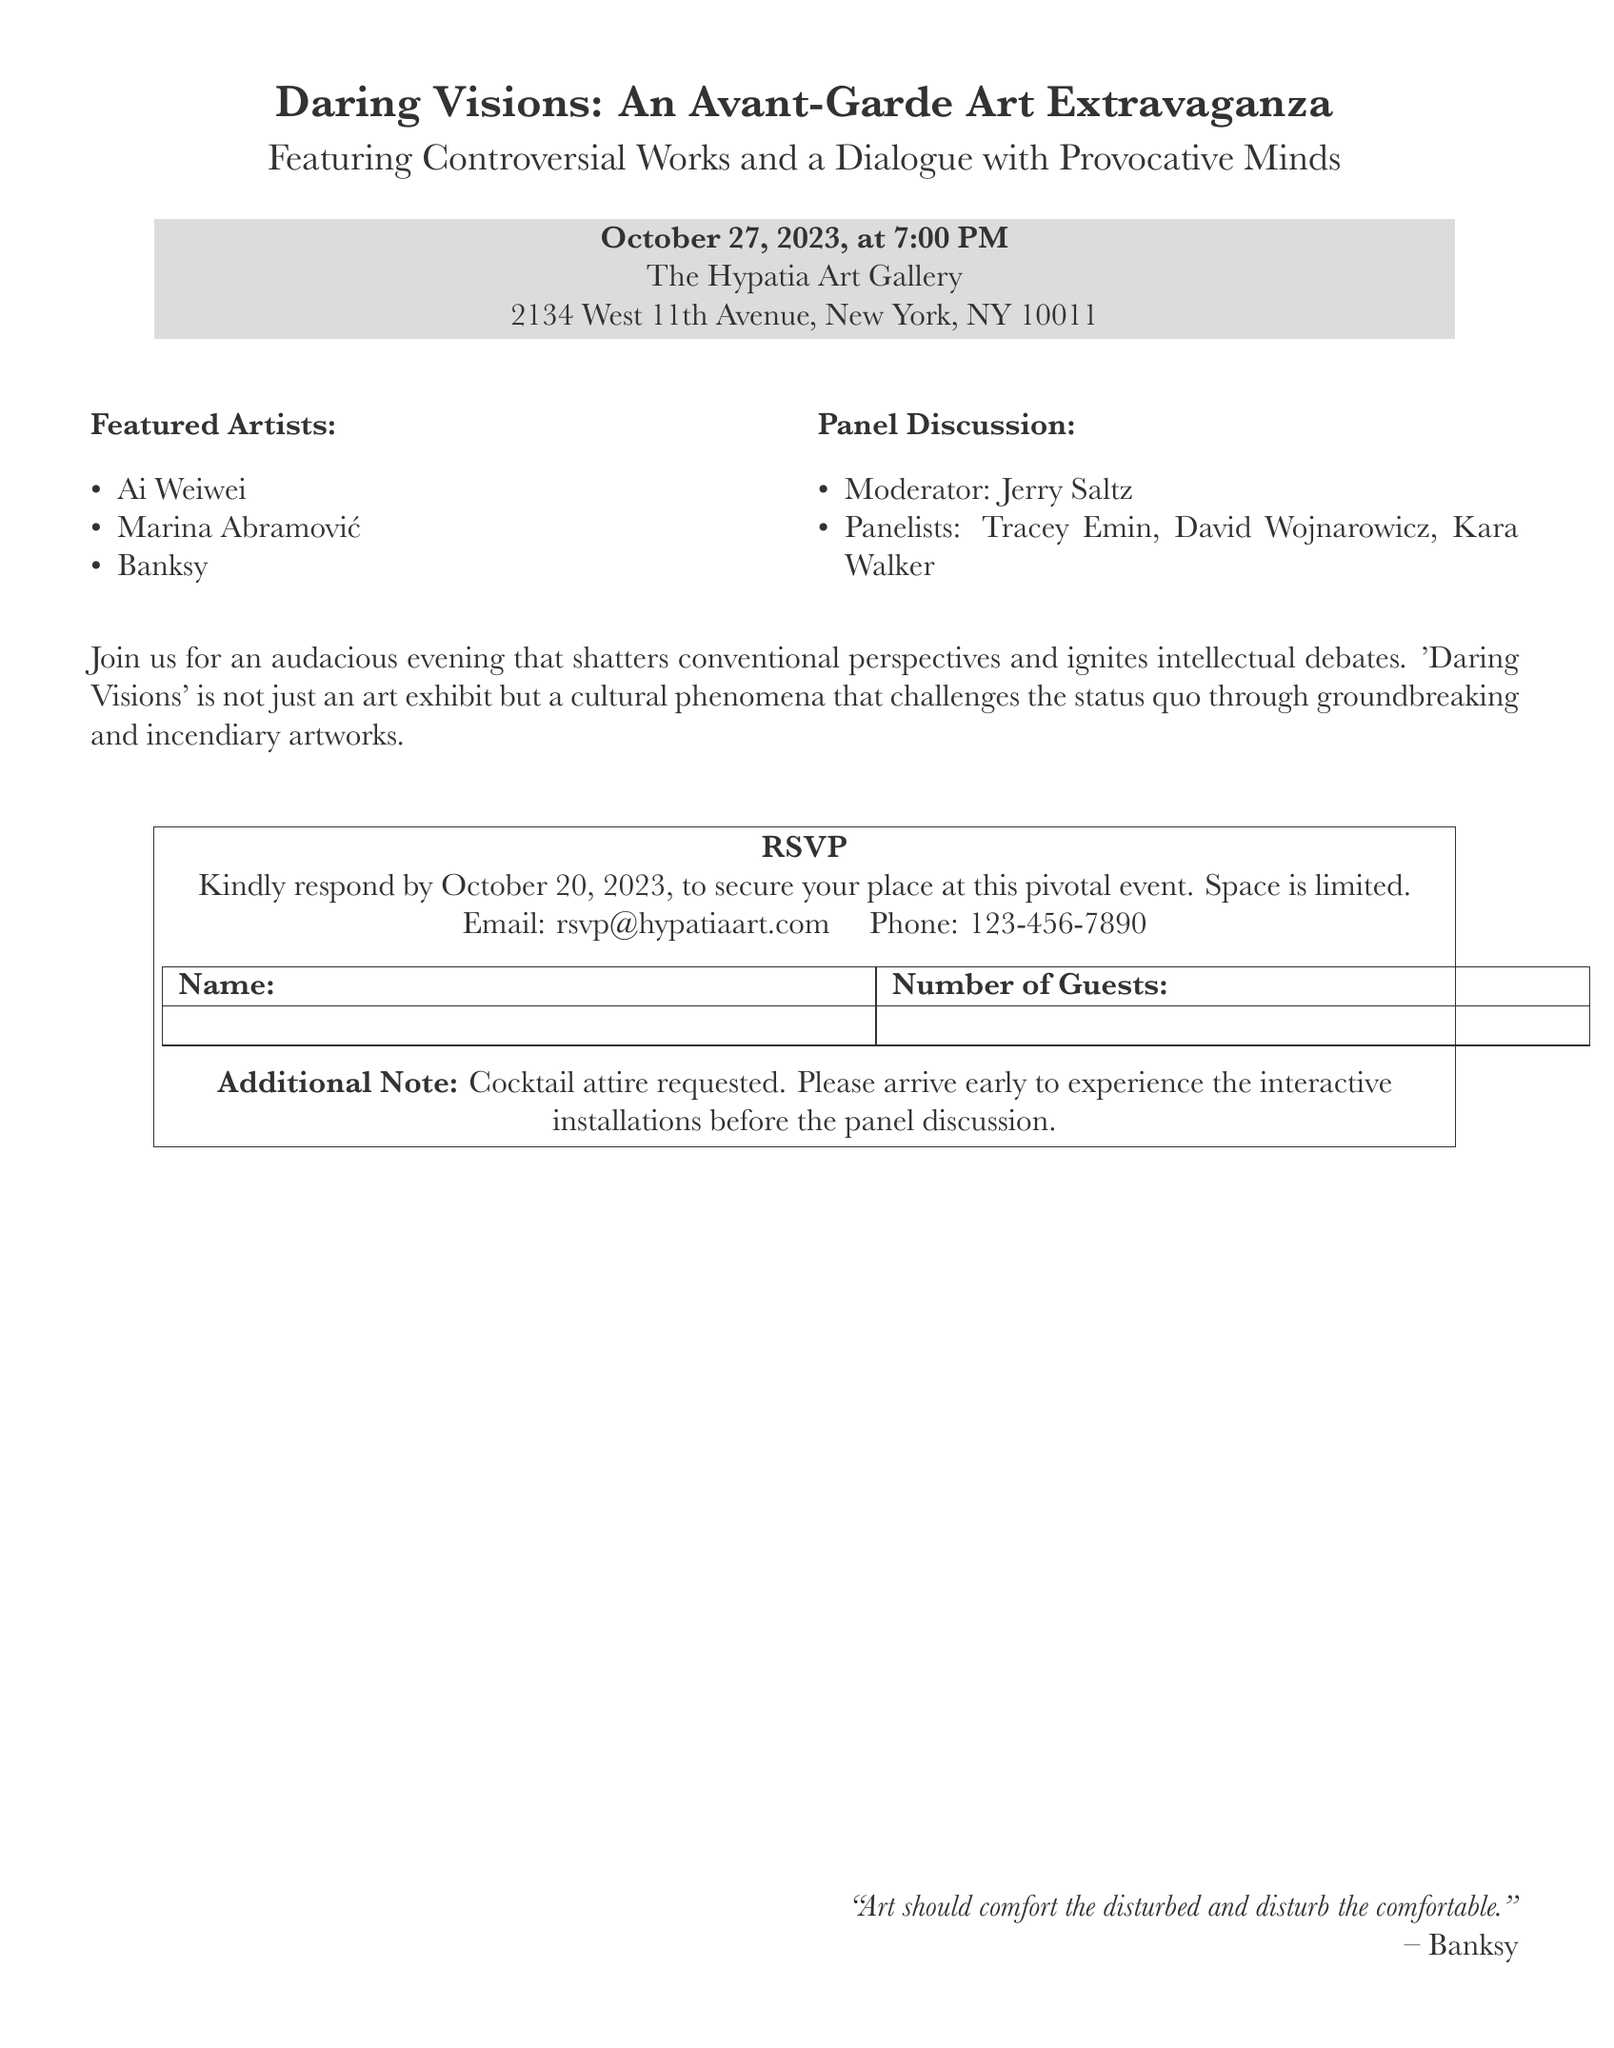What is the date of the event? The date of the event is specified in the document as October 27, 2023.
Answer: October 27, 2023 Who is the moderator for the panel discussion? The name of the moderator for the panel discussion is mentioned in the document as Jerry Saltz.
Answer: Jerry Saltz What type of attire is requested? The document specifies the requested attire for the event as cocktail attire.
Answer: Cocktail attire How many featured artists are listed? By counting the artists mentioned in the document under the featured artists section, there are three artists listed.
Answer: Three What is the RSVP email address? The email address provided for RSVPs in the document is rsvp@hypatiaart.com.
Answer: rsvp@hypatiaart.com What location is the gallery opening taking place? The location is given in the document as The Hypatia Art Gallery, 2134 West 11th Avenue, New York, NY 10011.
Answer: The Hypatia Art Gallery, 2134 West 11th Avenue, New York, NY 10011 When is the RSVP deadline? The document specifies that the RSVP deadline is October 20, 2023.
Answer: October 20, 2023 Who are the panelists participating in the discussion? The panelists mentioned in the document include Tracey Emin, David Wojnarowicz, and Kara Walker.
Answer: Tracey Emin, David Wojnarowicz, Kara Walker What can guests experience before the panel discussion? The document notes that guests are encouraged to arrive early to experience the interactive installations before the panel discussion.
Answer: Interactive installations 